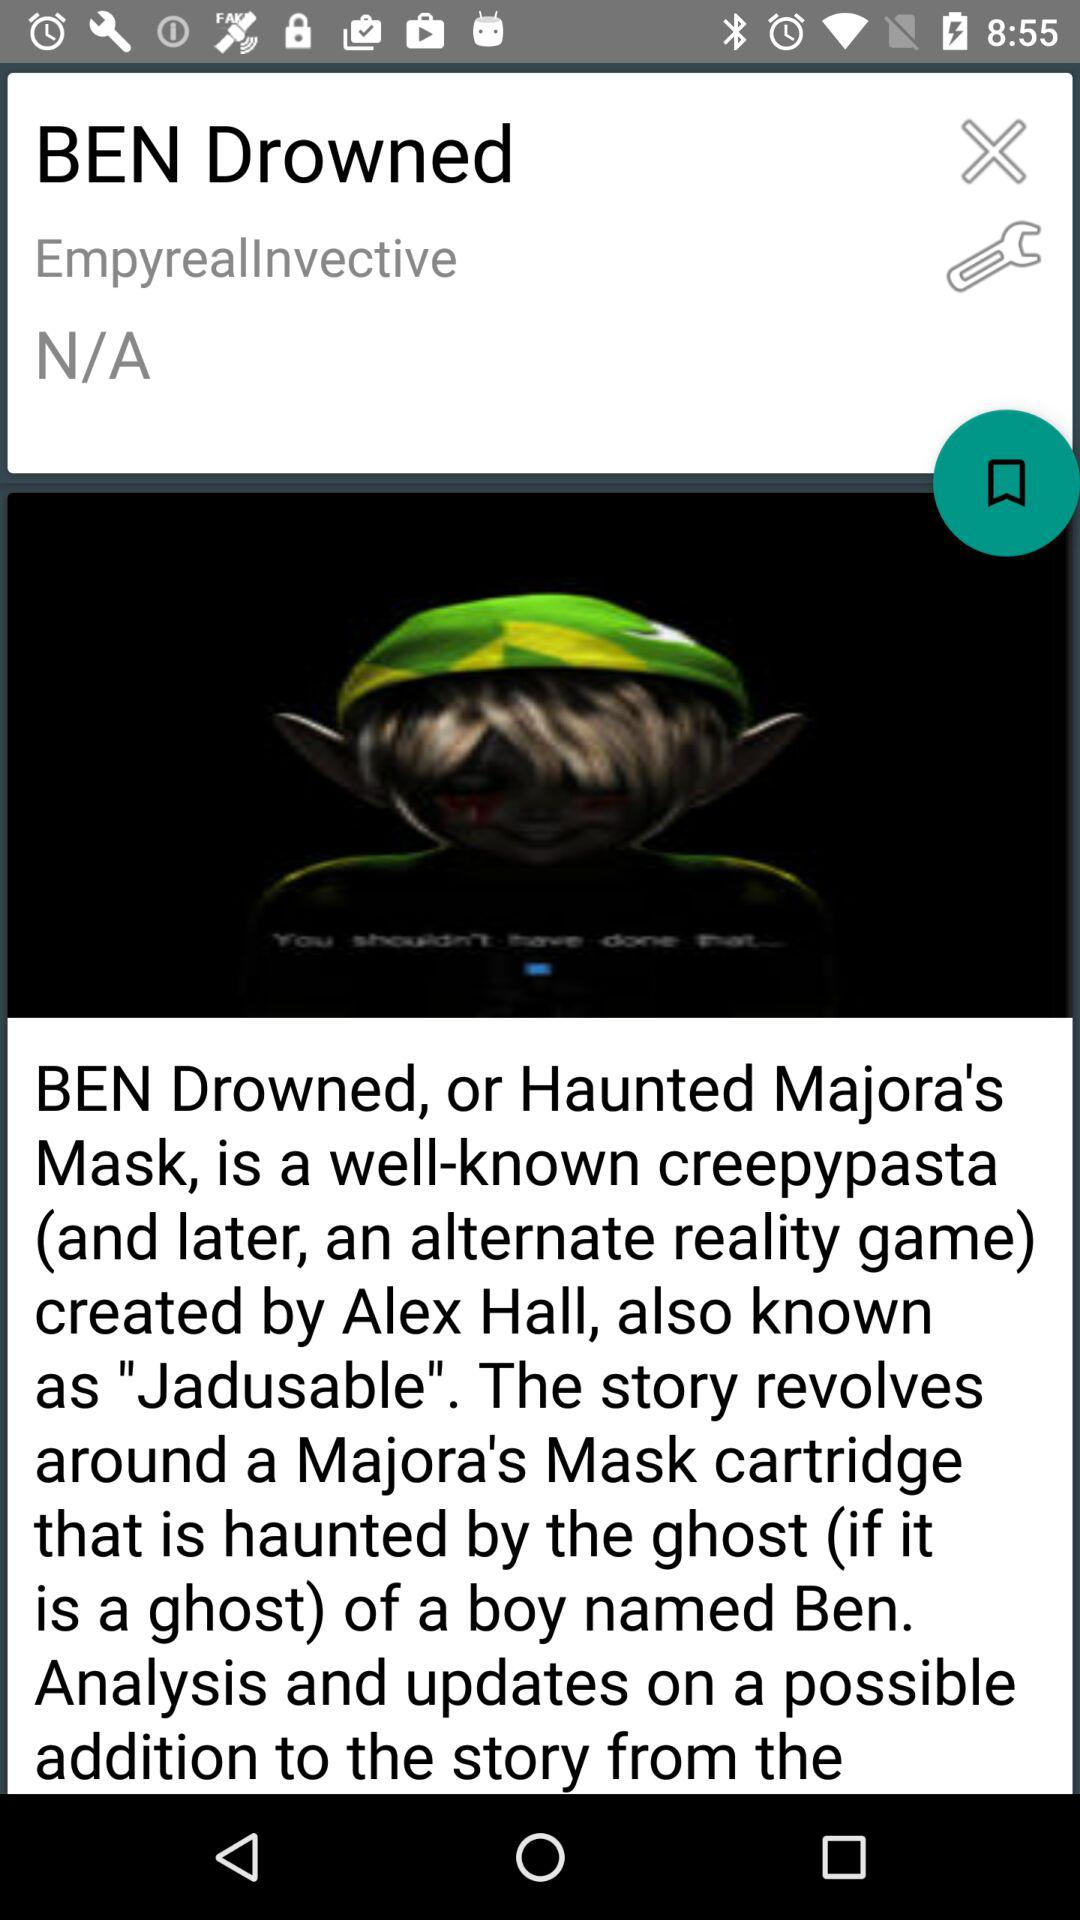Who is the creator of the game? The creator of the game is Alex Hall. 